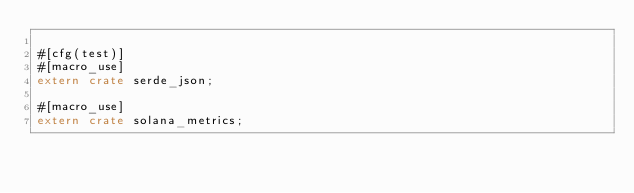<code> <loc_0><loc_0><loc_500><loc_500><_Rust_>
#[cfg(test)]
#[macro_use]
extern crate serde_json;

#[macro_use]
extern crate solana_metrics;
</code> 